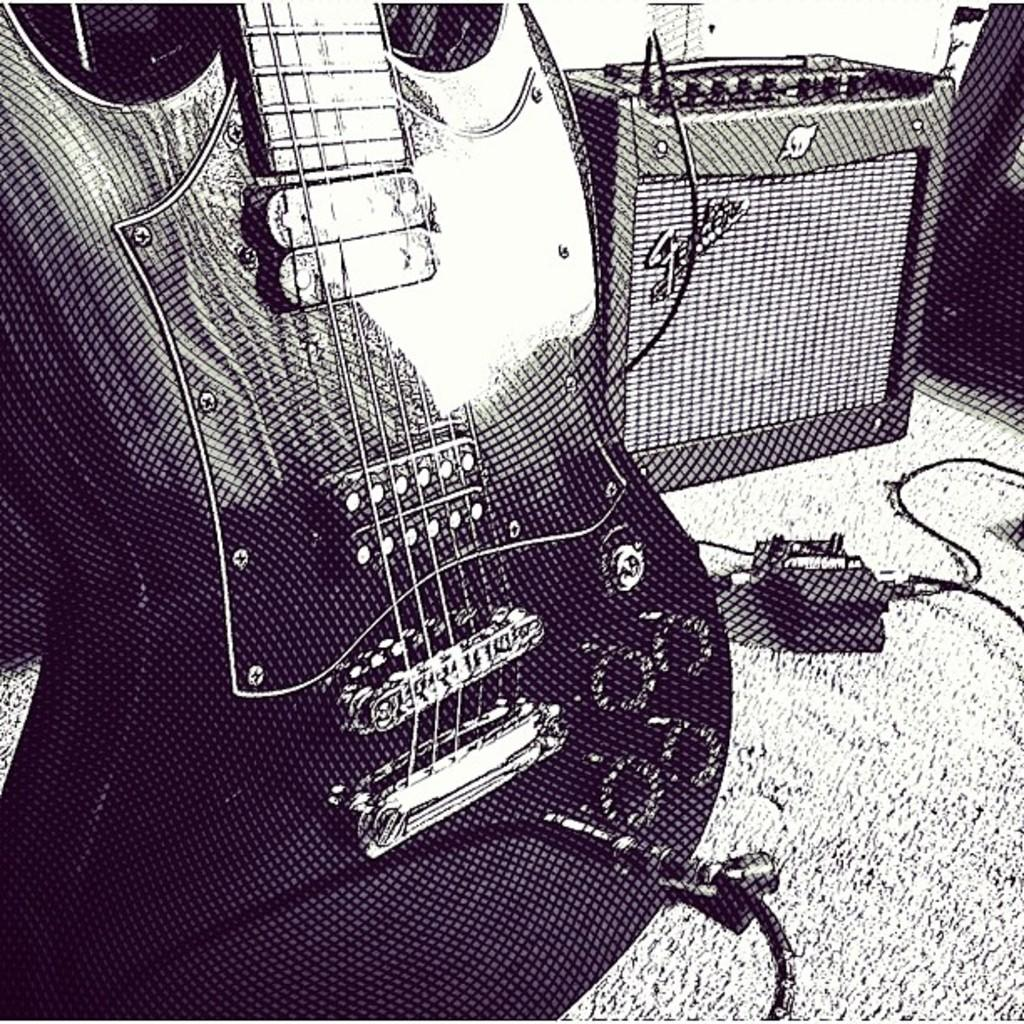What is the color scheme of the image? The image is black and white. What musical instrument can be seen in the image? There is a guitar in the image. What can be seen in the background of the image? There is a wire, a switch board, and an electronic device in the background of the image. What type of wood is used to make the guitar in the image? There is no information about the type of wood used to make the guitar in the image, as it is a black and white image and does not show the material of the guitar. 